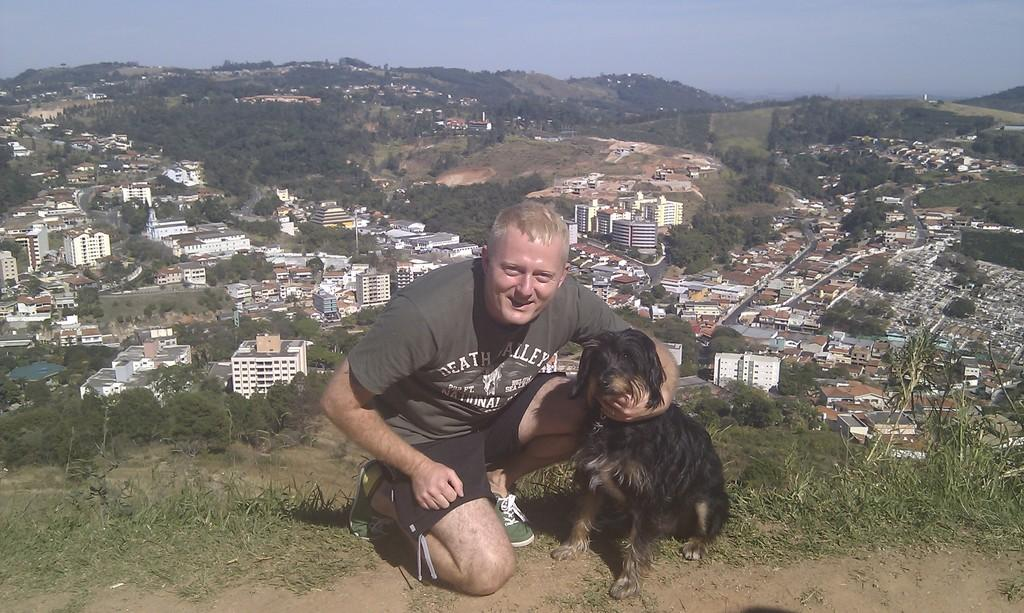What is the person in the image doing? The person is sitting in the image. What is the person holding? The person is holding a dog. What can be seen behind the person? There are trees and a building behind the person. What type of landscape is visible in the background? There are hills visible in the background. What type of substance is the person using to control the dog in the image? There is no indication in the image that the person is using any substance to control the dog. 